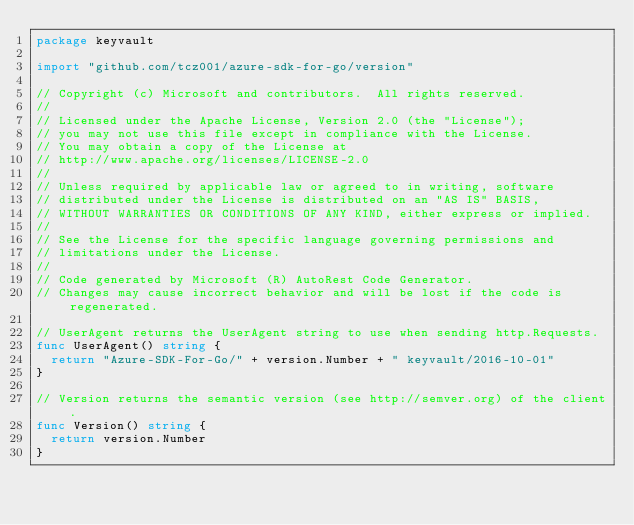<code> <loc_0><loc_0><loc_500><loc_500><_Go_>package keyvault

import "github.com/tcz001/azure-sdk-for-go/version"

// Copyright (c) Microsoft and contributors.  All rights reserved.
//
// Licensed under the Apache License, Version 2.0 (the "License");
// you may not use this file except in compliance with the License.
// You may obtain a copy of the License at
// http://www.apache.org/licenses/LICENSE-2.0
//
// Unless required by applicable law or agreed to in writing, software
// distributed under the License is distributed on an "AS IS" BASIS,
// WITHOUT WARRANTIES OR CONDITIONS OF ANY KIND, either express or implied.
//
// See the License for the specific language governing permissions and
// limitations under the License.
//
// Code generated by Microsoft (R) AutoRest Code Generator.
// Changes may cause incorrect behavior and will be lost if the code is regenerated.

// UserAgent returns the UserAgent string to use when sending http.Requests.
func UserAgent() string {
	return "Azure-SDK-For-Go/" + version.Number + " keyvault/2016-10-01"
}

// Version returns the semantic version (see http://semver.org) of the client.
func Version() string {
	return version.Number
}
</code> 